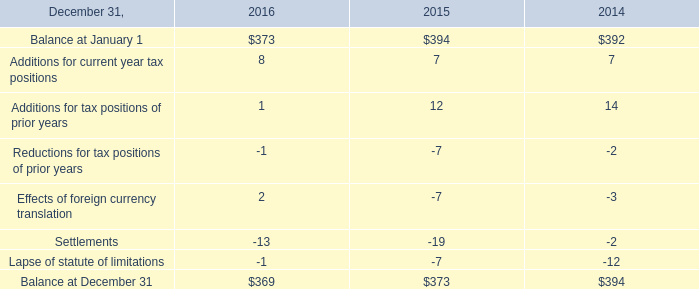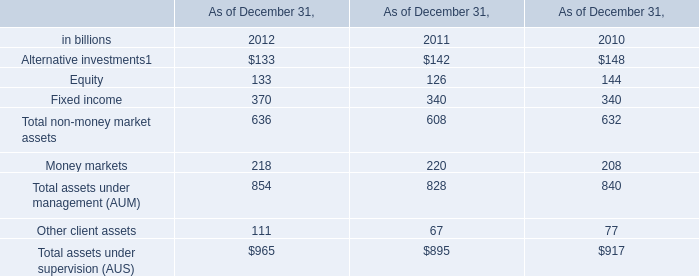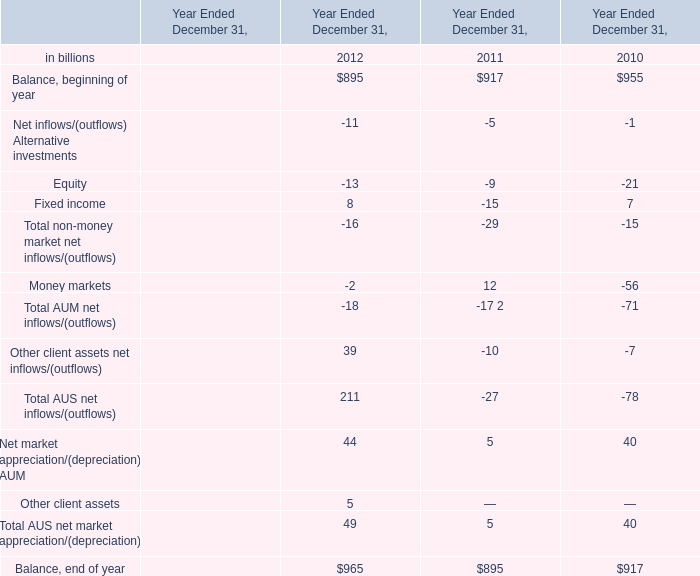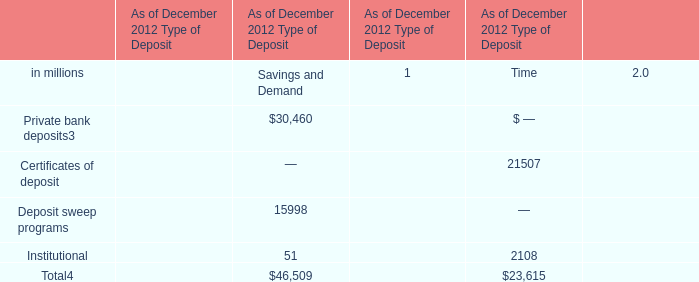What is the growing rate of Money markets in the years with the leastTotal non-money market assets? (in %) 
Computations: ((220 - 208) / 208)
Answer: 0.05769. 